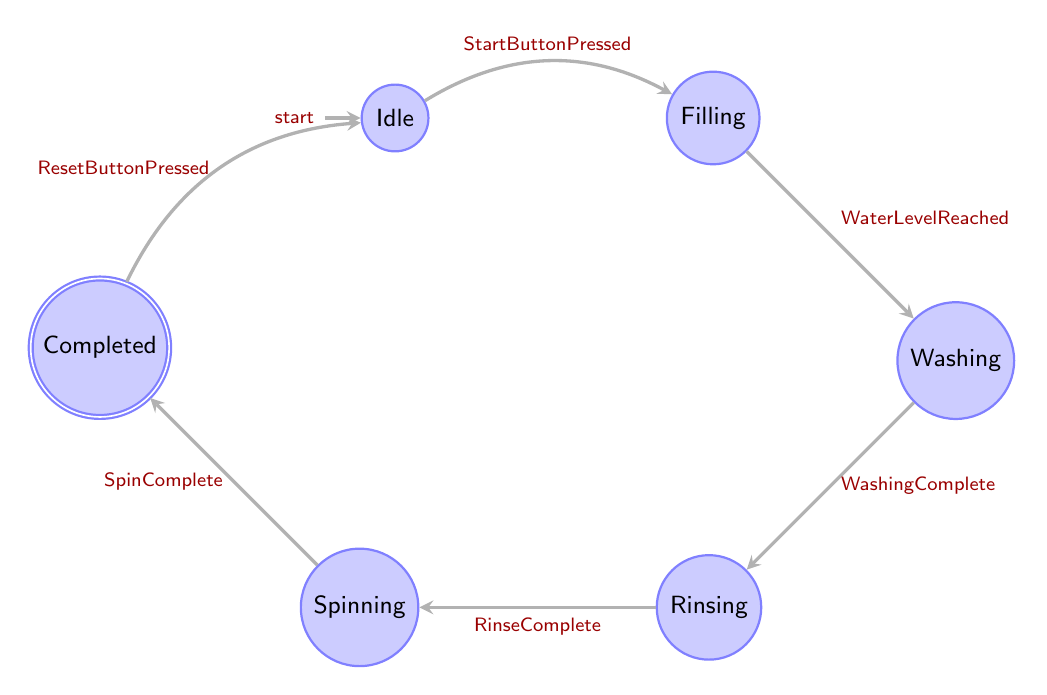What is the initial state of the washing machine cycle? The initial state of the washing machine cycle is labeled as "Idle" in the diagram, indicated by the arrow pointing to this state from nowhere.
Answer: Idle How many states are present in the diagram? The diagram shows six distinct states: Idle, Filling, Washing, Rinsing, Spinning, and Completed.
Answer: 6 What action leads from Filling to Washing? The action that transitions the state from Filling to Washing is labeled "WaterLevelReached" on the arrow connecting the two states.
Answer: WaterLevelReached Which state does the washing machine transition to after Rinsing? After the Rinsing state, the washing machine transitions to the Spinning state, as indicated by the directed edge between Rinsing and Spinning.
Answer: Spinning What is the final state of the washing machine cycle? The final state in the sequence of states is "Completed," as it is the last node reached before transitioning back to Idle.
Answer: Completed What action is required to return to the Idle state from Completed? The action needed to return to the Idle state from Completed is labeled as "ResetButtonPressed" on the arrow that loops back to Idle.
Answer: ResetButtonPressed In total, how many transitions are there in the diagram? The diagram contains six transitions: from Idle to Filling, Filling to Washing, Washing to Rinsing, Rinsing to Spinning, Spinning to Completed, and Completed back to Idle.
Answer: 6 Which state does the washing machine enter after the washing process is complete? After the washing process is complete, indicated by the "WashingComplete" action, the washing machine enters the Rinsing state, as shown in the transition.
Answer: Rinsing What direction do the transitions flow in the diagram from Filling to Completed? The transitions flow sequentially from Filling to Washing, then to Rinsing, followed by Spinning, and finally to Completed, creating a linear path through the states.
Answer: Sequential 